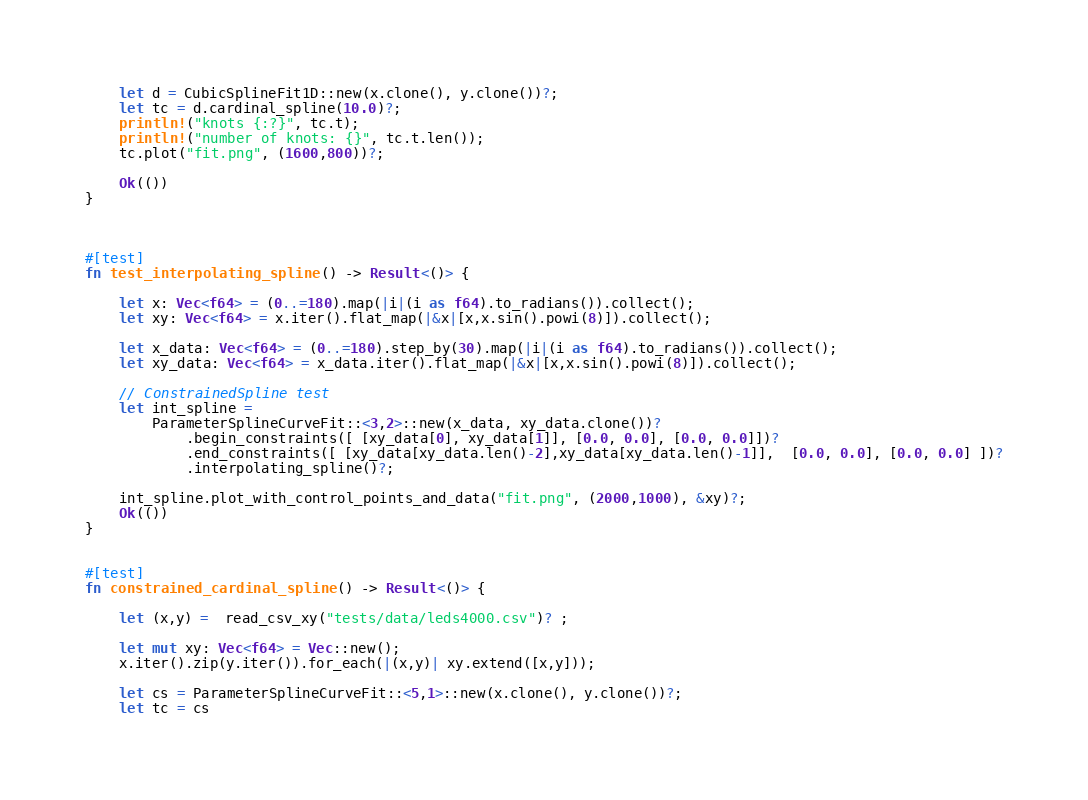<code> <loc_0><loc_0><loc_500><loc_500><_Rust_>    let d = CubicSplineFit1D::new(x.clone(), y.clone())?;
    let tc = d.cardinal_spline(10.0)?;
    println!("knots {:?}", tc.t);
    println!("number of knots: {}", tc.t.len());
    tc.plot("fit.png", (1600,800))?;

    Ok(())
}



#[test]
fn test_interpolating_spline() -> Result<()> {

    let x: Vec<f64> = (0..=180).map(|i|(i as f64).to_radians()).collect();
    let xy: Vec<f64> = x.iter().flat_map(|&x|[x,x.sin().powi(8)]).collect();

    let x_data: Vec<f64> = (0..=180).step_by(30).map(|i|(i as f64).to_radians()).collect();
    let xy_data: Vec<f64> = x_data.iter().flat_map(|&x|[x,x.sin().powi(8)]).collect();

    // ConstrainedSpline test
    let int_spline =
        ParameterSplineCurveFit::<3,2>::new(x_data, xy_data.clone())?
            .begin_constraints([ [xy_data[0], xy_data[1]], [0.0, 0.0], [0.0, 0.0]])?
            .end_constraints([ [xy_data[xy_data.len()-2],xy_data[xy_data.len()-1]],  [0.0, 0.0], [0.0, 0.0] ])?
            .interpolating_spline()?;
    
    int_spline.plot_with_control_points_and_data("fit.png", (2000,1000), &xy)?;
    Ok(())
}


#[test]
fn constrained_cardinal_spline() -> Result<()> {

    let (x,y) =  read_csv_xy("tests/data/leds4000.csv")? ;

    let mut xy: Vec<f64> = Vec::new();
    x.iter().zip(y.iter()).for_each(|(x,y)| xy.extend([x,y]));

    let cs = ParameterSplineCurveFit::<5,1>::new(x.clone(), y.clone())?;
    let tc = cs</code> 